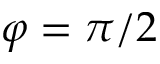<formula> <loc_0><loc_0><loc_500><loc_500>\varphi = \pi / 2</formula> 